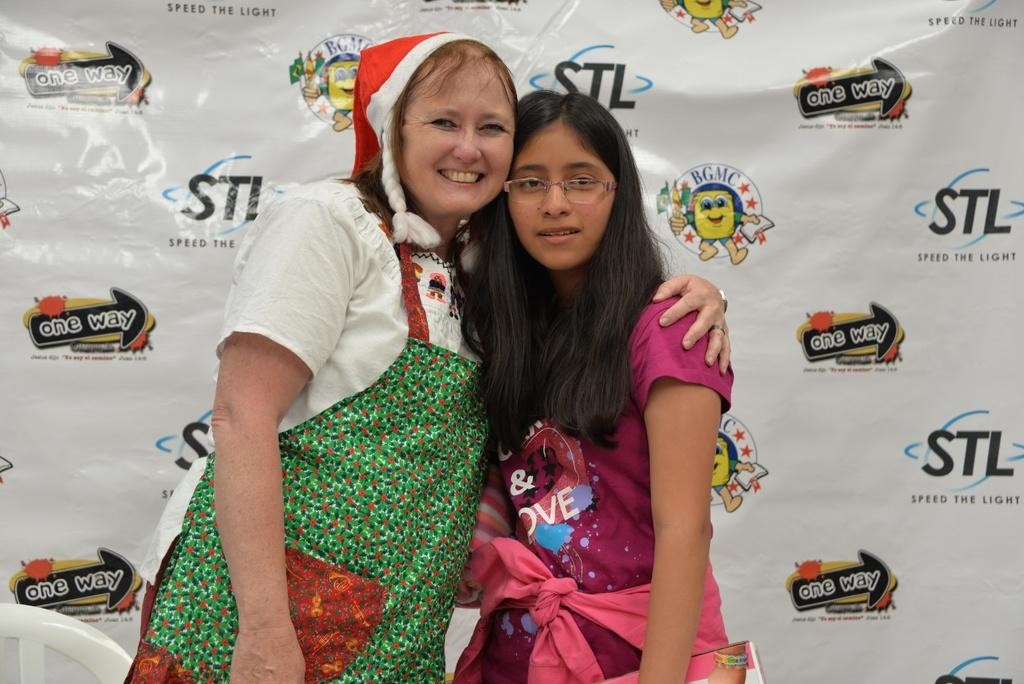What can be observed about the people in the image? There are people standing in the image. Can you describe the attire of one of the individuals? A woman is wearing a Christmas cap. What additional element is present in the image? There is a banner visible in the image. What type of thread is being used to sew the kettle in the image? There is no kettle present in the image, so it is not possible to determine what type of thread might be used. 